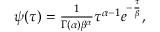Convert formula to latex. <formula><loc_0><loc_0><loc_500><loc_500>\begin{array} { r } { \psi ( \tau ) = \frac { 1 } { \Gamma ( \alpha ) \beta ^ { \alpha } } \tau ^ { \alpha - 1 } e ^ { - \frac { \tau } { \beta } } , } \end{array}</formula> 